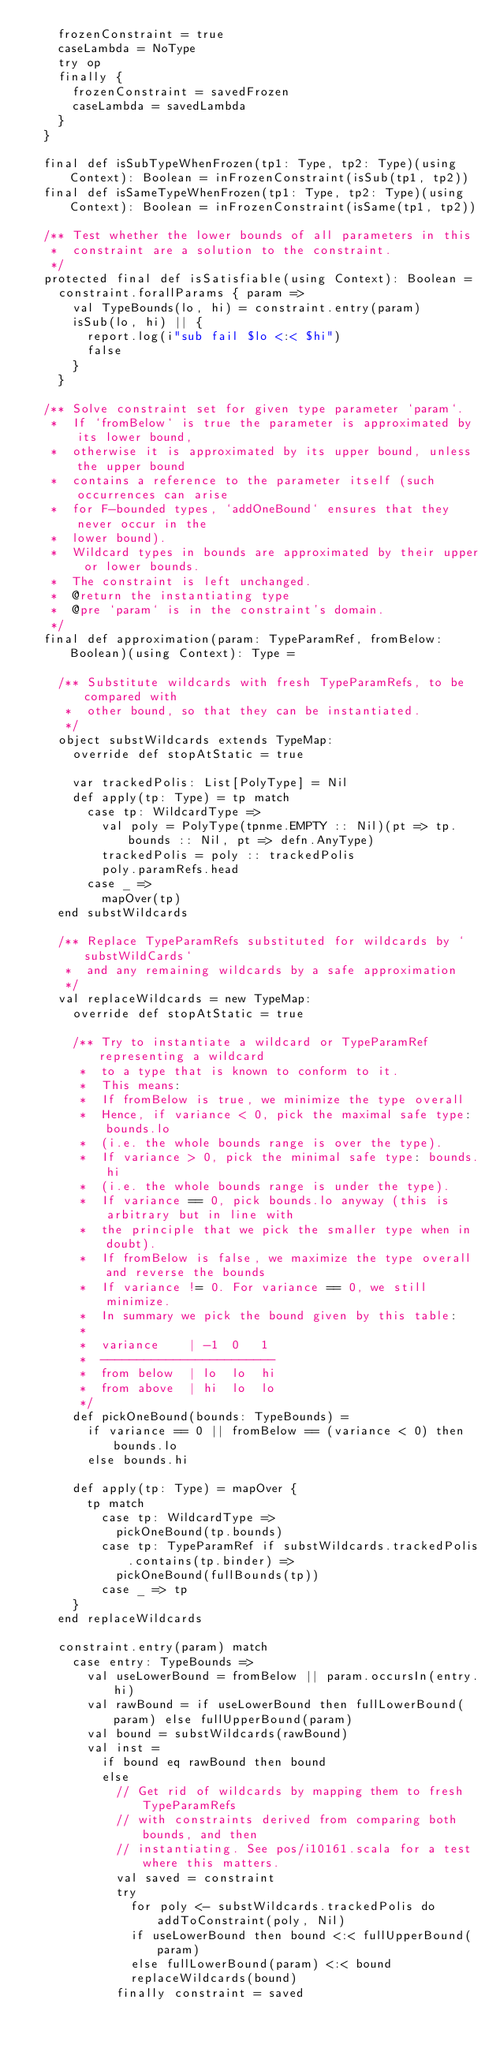Convert code to text. <code><loc_0><loc_0><loc_500><loc_500><_Scala_>    frozenConstraint = true
    caseLambda = NoType
    try op
    finally {
      frozenConstraint = savedFrozen
      caseLambda = savedLambda
    }
  }

  final def isSubTypeWhenFrozen(tp1: Type, tp2: Type)(using Context): Boolean = inFrozenConstraint(isSub(tp1, tp2))
  final def isSameTypeWhenFrozen(tp1: Type, tp2: Type)(using Context): Boolean = inFrozenConstraint(isSame(tp1, tp2))

  /** Test whether the lower bounds of all parameters in this
   *  constraint are a solution to the constraint.
   */
  protected final def isSatisfiable(using Context): Boolean =
    constraint.forallParams { param =>
      val TypeBounds(lo, hi) = constraint.entry(param)
      isSub(lo, hi) || {
        report.log(i"sub fail $lo <:< $hi")
        false
      }
    }

  /** Solve constraint set for given type parameter `param`.
   *  If `fromBelow` is true the parameter is approximated by its lower bound,
   *  otherwise it is approximated by its upper bound, unless the upper bound
   *  contains a reference to the parameter itself (such occurrences can arise
   *  for F-bounded types, `addOneBound` ensures that they never occur in the
   *  lower bound).
   *  Wildcard types in bounds are approximated by their upper or lower bounds.
   *  The constraint is left unchanged.
   *  @return the instantiating type
   *  @pre `param` is in the constraint's domain.
   */
  final def approximation(param: TypeParamRef, fromBelow: Boolean)(using Context): Type =

    /** Substitute wildcards with fresh TypeParamRefs, to be compared with
     *  other bound, so that they can be instantiated.
     */
    object substWildcards extends TypeMap:
      override def stopAtStatic = true

      var trackedPolis: List[PolyType] = Nil
      def apply(tp: Type) = tp match
        case tp: WildcardType =>
          val poly = PolyType(tpnme.EMPTY :: Nil)(pt => tp.bounds :: Nil, pt => defn.AnyType)
          trackedPolis = poly :: trackedPolis
          poly.paramRefs.head
        case _ =>
          mapOver(tp)
    end substWildcards

    /** Replace TypeParamRefs substituted for wildcards by `substWildCards`
     *  and any remaining wildcards by a safe approximation
     */
    val replaceWildcards = new TypeMap:
      override def stopAtStatic = true

      /** Try to instantiate a wildcard or TypeParamRef representing a wildcard
       *  to a type that is known to conform to it.
       *  This means:
       *  If fromBelow is true, we minimize the type overall
       *  Hence, if variance < 0, pick the maximal safe type: bounds.lo
       *  (i.e. the whole bounds range is over the type).
       *  If variance > 0, pick the minimal safe type: bounds.hi
       *  (i.e. the whole bounds range is under the type).
       *  If variance == 0, pick bounds.lo anyway (this is arbitrary but in line with
       *  the principle that we pick the smaller type when in doubt).
       *  If fromBelow is false, we maximize the type overall and reverse the bounds
       *  If variance != 0. For variance == 0, we still minimize.
       *  In summary we pick the bound given by this table:
       *
       *  variance    | -1  0   1
       *  ------------------------
       *  from below  | lo  lo  hi
       *  from above  | hi  lo  lo
       */
      def pickOneBound(bounds: TypeBounds) =
        if variance == 0 || fromBelow == (variance < 0) then bounds.lo
        else bounds.hi

      def apply(tp: Type) = mapOver {
        tp match
          case tp: WildcardType =>
            pickOneBound(tp.bounds)
          case tp: TypeParamRef if substWildcards.trackedPolis.contains(tp.binder) =>
            pickOneBound(fullBounds(tp))
          case _ => tp
      }
    end replaceWildcards

    constraint.entry(param) match
      case entry: TypeBounds =>
        val useLowerBound = fromBelow || param.occursIn(entry.hi)
        val rawBound = if useLowerBound then fullLowerBound(param) else fullUpperBound(param)
        val bound = substWildcards(rawBound)
        val inst =
          if bound eq rawBound then bound
          else
            // Get rid of wildcards by mapping them to fresh TypeParamRefs
            // with constraints derived from comparing both bounds, and then
            // instantiating. See pos/i10161.scala for a test where this matters.
            val saved = constraint
            try
              for poly <- substWildcards.trackedPolis do addToConstraint(poly, Nil)
              if useLowerBound then bound <:< fullUpperBound(param)
              else fullLowerBound(param) <:< bound
              replaceWildcards(bound)
            finally constraint = saved</code> 